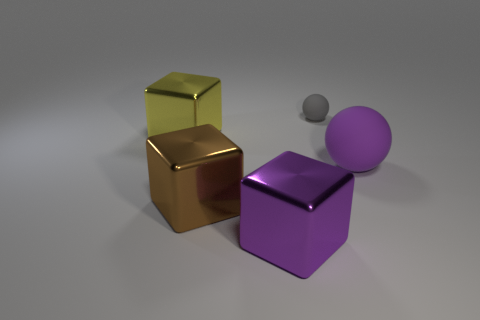What size is the block that is the same color as the large ball?
Your answer should be very brief. Large. There is a rubber object in front of the yellow object; does it have the same shape as the big purple thing that is on the left side of the tiny gray matte object?
Ensure brevity in your answer.  No. There is a tiny rubber sphere; what number of purple things are on the right side of it?
Your response must be concise. 1. Do the purple object that is right of the purple metal object and the gray object have the same material?
Your answer should be very brief. Yes. There is another object that is the same shape as the small gray matte thing; what color is it?
Your response must be concise. Purple. What shape is the purple matte thing?
Provide a short and direct response. Sphere. How many things are either tiny cyan matte things or brown metallic cubes?
Offer a very short reply. 1. Is the color of the rubber thing in front of the big yellow shiny block the same as the metal cube to the left of the brown thing?
Ensure brevity in your answer.  No. What number of other things are there of the same shape as the brown thing?
Your answer should be compact. 2. Are any tiny brown metal spheres visible?
Make the answer very short. No. 